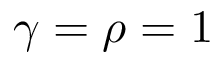<formula> <loc_0><loc_0><loc_500><loc_500>\gamma = \rho = 1</formula> 